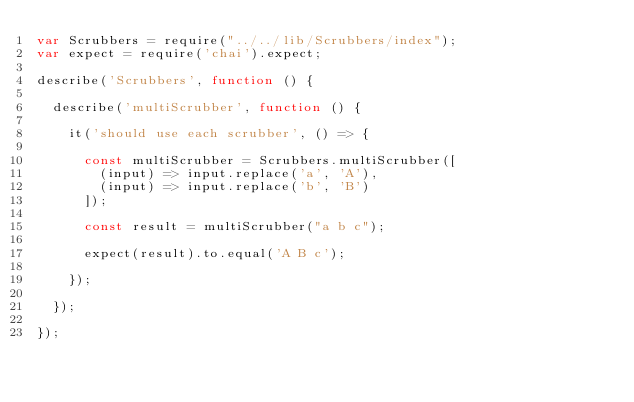<code> <loc_0><loc_0><loc_500><loc_500><_JavaScript_>var Scrubbers = require("../../lib/Scrubbers/index");
var expect = require('chai').expect;

describe('Scrubbers', function () {

  describe('multiScrubber', function () {

    it('should use each scrubber', () => {

      const multiScrubber = Scrubbers.multiScrubber([
        (input) => input.replace('a', 'A'),
        (input) => input.replace('b', 'B')
      ]);

      const result = multiScrubber("a b c");

      expect(result).to.equal('A B c');

    });

  });

});
</code> 